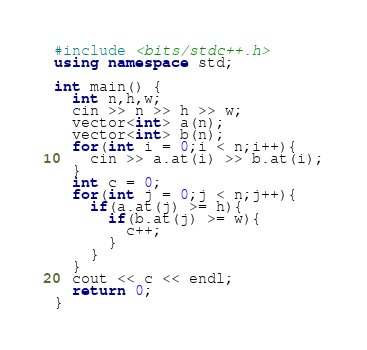<code> <loc_0><loc_0><loc_500><loc_500><_C++_>#include <bits/stdc++.h>
using namespace std;

int main() {
  int n,h,w;
  cin >> n >> h >> w;
  vector<int> a(n);
  vector<int> b(n);
  for(int i = 0;i < n;i++){
    cin >> a.at(i) >> b.at(i);
  }
  int c = 0;
  for(int j = 0;j < n;j++){
	if(a.at(j) >= h){
      if(b.at(j) >= w){
        c++;
      }
    }
  }
  cout << c << endl;
  return 0;
}</code> 